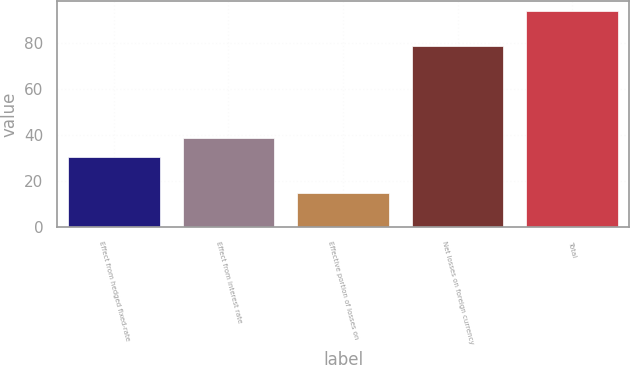Convert chart to OTSL. <chart><loc_0><loc_0><loc_500><loc_500><bar_chart><fcel>Effect from hedged fixed-rate<fcel>Effect from interest rate<fcel>Effective portion of losses on<fcel>Net losses on foreign currency<fcel>Total<nl><fcel>30.8<fcel>38.68<fcel>15<fcel>78.8<fcel>93.8<nl></chart> 